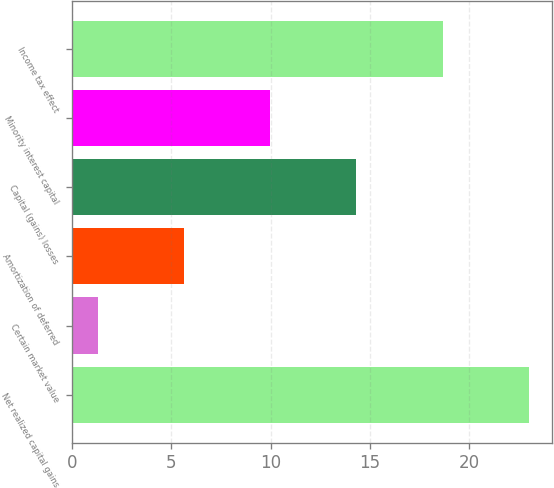Convert chart to OTSL. <chart><loc_0><loc_0><loc_500><loc_500><bar_chart><fcel>Net realized capital gains<fcel>Certain market value<fcel>Amortization of deferred<fcel>Capital (gains) losses<fcel>Minority interest capital<fcel>Income tax effect<nl><fcel>23<fcel>1.3<fcel>5.64<fcel>14.32<fcel>9.98<fcel>18.66<nl></chart> 